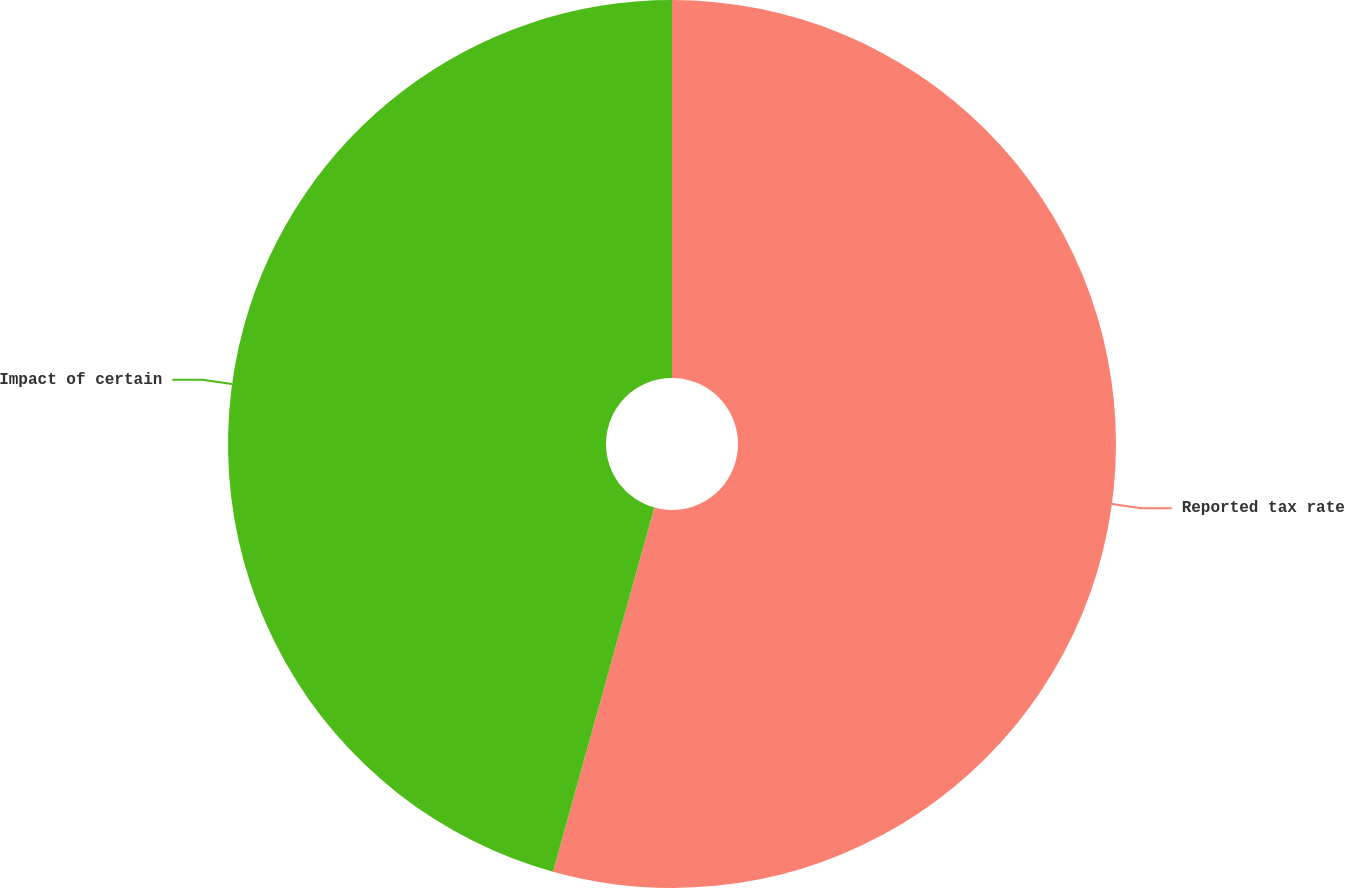Convert chart to OTSL. <chart><loc_0><loc_0><loc_500><loc_500><pie_chart><fcel>Reported tax rate<fcel>Impact of certain<nl><fcel>54.32%<fcel>45.68%<nl></chart> 